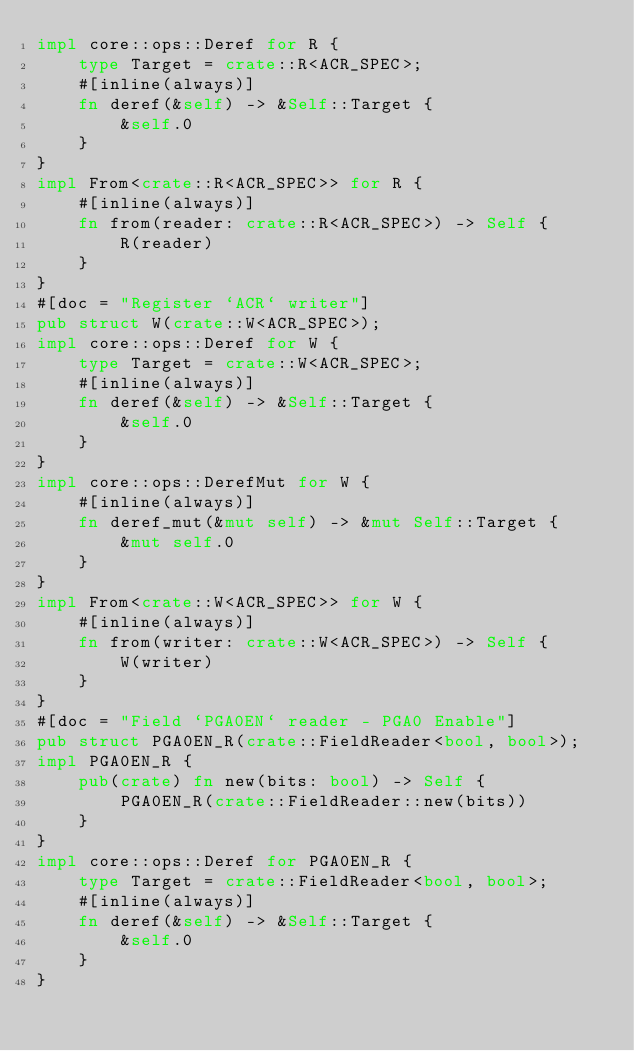<code> <loc_0><loc_0><loc_500><loc_500><_Rust_>impl core::ops::Deref for R {
    type Target = crate::R<ACR_SPEC>;
    #[inline(always)]
    fn deref(&self) -> &Self::Target {
        &self.0
    }
}
impl From<crate::R<ACR_SPEC>> for R {
    #[inline(always)]
    fn from(reader: crate::R<ACR_SPEC>) -> Self {
        R(reader)
    }
}
#[doc = "Register `ACR` writer"]
pub struct W(crate::W<ACR_SPEC>);
impl core::ops::Deref for W {
    type Target = crate::W<ACR_SPEC>;
    #[inline(always)]
    fn deref(&self) -> &Self::Target {
        &self.0
    }
}
impl core::ops::DerefMut for W {
    #[inline(always)]
    fn deref_mut(&mut self) -> &mut Self::Target {
        &mut self.0
    }
}
impl From<crate::W<ACR_SPEC>> for W {
    #[inline(always)]
    fn from(writer: crate::W<ACR_SPEC>) -> Self {
        W(writer)
    }
}
#[doc = "Field `PGA0EN` reader - PGA0 Enable"]
pub struct PGA0EN_R(crate::FieldReader<bool, bool>);
impl PGA0EN_R {
    pub(crate) fn new(bits: bool) -> Self {
        PGA0EN_R(crate::FieldReader::new(bits))
    }
}
impl core::ops::Deref for PGA0EN_R {
    type Target = crate::FieldReader<bool, bool>;
    #[inline(always)]
    fn deref(&self) -> &Self::Target {
        &self.0
    }
}</code> 